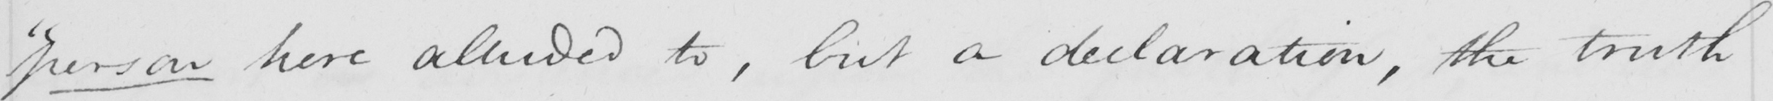What does this handwritten line say? " person here alluded to , but a declaration , the truth 